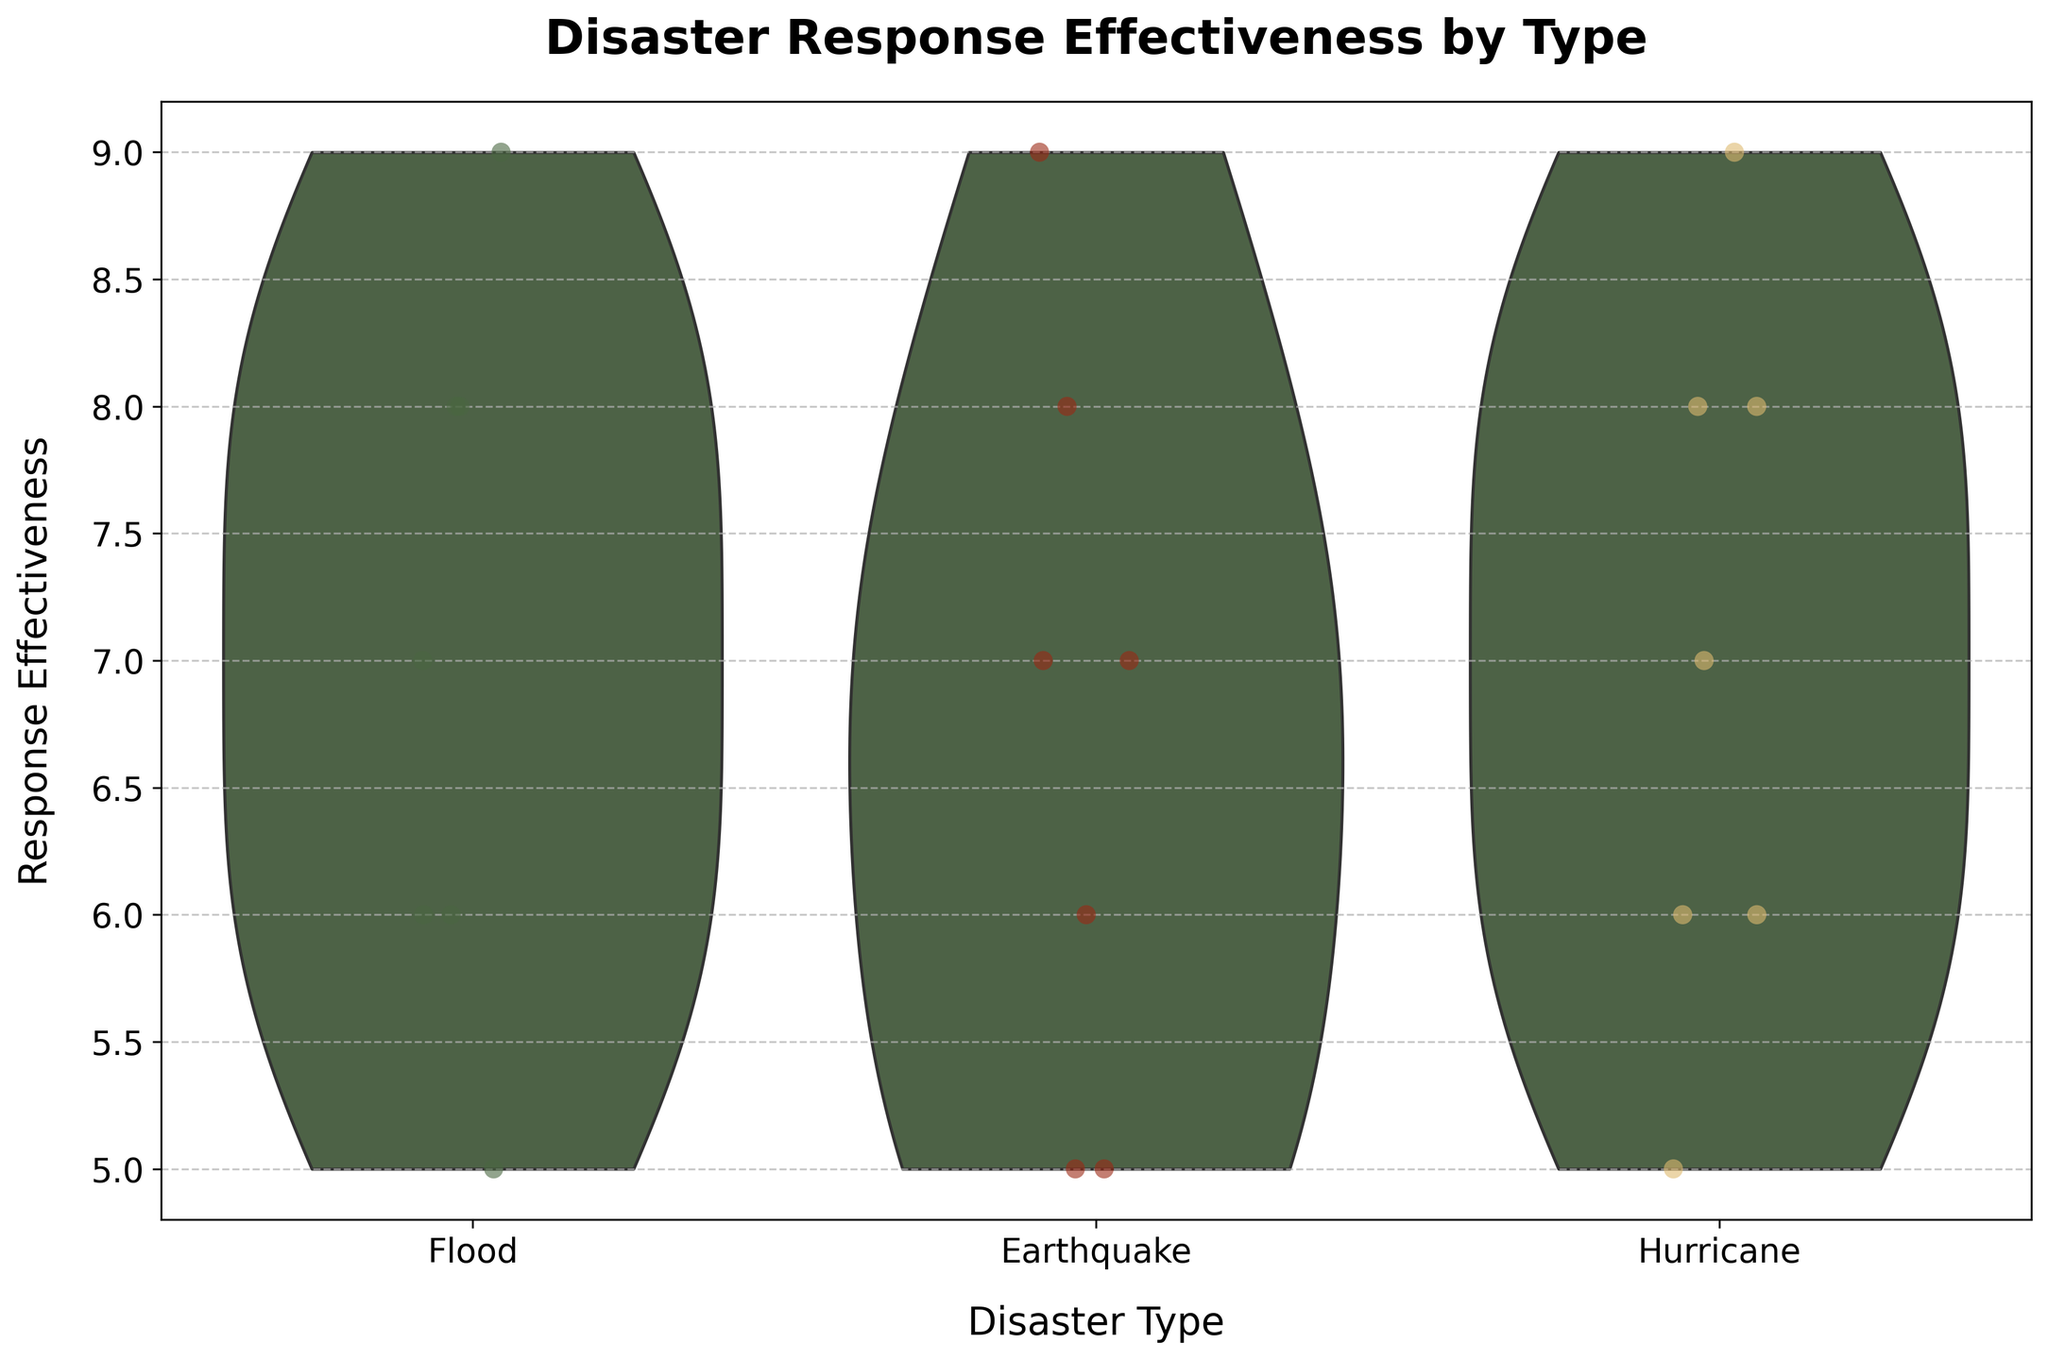What is the title of the chart? The title of the chart is displayed at the top and reads 'Disaster Response Effectiveness by Type'.
Answer: Disaster Response Effectiveness by Type Which disaster type has the highest response effectiveness point? Looking at the jittered points within each violin plot, the highest response effectiveness point of 9 is present in the categories of Floods, Earthquakes, and Hurricanes.
Answer: Floods, Earthquakes, and Hurricanes How do the distributions of response effectiveness compare between hurricanes and floods? The width and spread of the violin plots can help us compare distributions. The distribution for Hurricanes shows a higher concentration around effectiveness values of 6-8, while Floods have a wider spread but also center around 6-8 with some values reaching 9.
Answer: Both distributions center around 6-8 but with Floods showing a wider range What is the lowest response effectiveness value mentioned for earthquakes? The smallest point within the earthquake segment signifies this value, which is located at the value of 5.
Answer: 5 Which disaster type shows the most spread in response effectiveness points? The width and overall spread of the violin plots visually show this, with Floods having the widest plot, thus representing the most variability in response effectiveness points.
Answer: Floods What specific effectiveness values are predominantly seen for hurricanes? By looking at the jittered points and the thickest part of the violin plot, we can identify that values predominantly range between 6 and 8 for hurricanes.
Answer: 6 and 8 Which region has the highest response effectiveness for Hurricane disasters? Referring to the jittered points, the region associated with the highest effectiveness value of 9 for Hurricanes is Louisiana.
Answer: Louisiana Is there any disaster type where the response effectiveness includes two points at both extremes of the scale presented? By examining each violin plot, Earthquakes and Floods show both low (5) and high (9) effectiveness points, covering both extremes of the scale.
Answer: Earthquakes and Floods Which disaster type has the lowest median response effectiveness value? By partially visual inspection of the density distribution within the violins, it appears that Earthquakes might have a median response effectiveness value skewed towards lower effectiveness compared to Floods or Hurricanes.
Answer: Earthquakes How many response effectiveness points are exactly 8 in the hurricane category? Two jittered points are seen at the response effectiveness value of 8 within the plot for hurricanes.
Answer: 2 